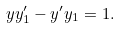<formula> <loc_0><loc_0><loc_500><loc_500>y y _ { 1 } ^ { \prime } - y ^ { \prime } y _ { 1 } = 1 .</formula> 